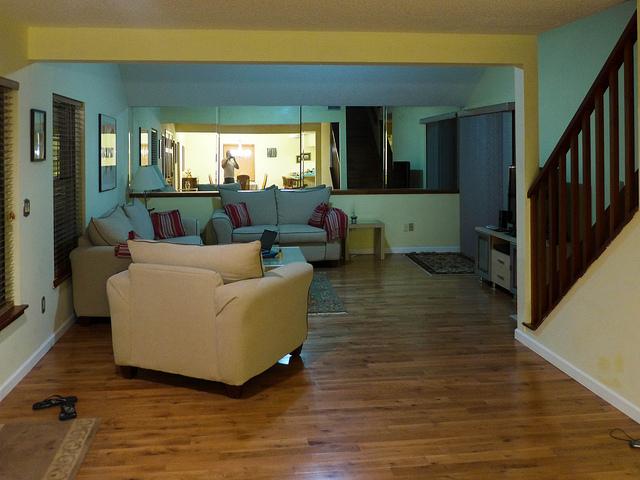Can you spot the guy in the mirror?
Short answer required. Yes. What is the flooring made of?
Concise answer only. Wood. What room is this a picture of?
Write a very short answer. Living room. Is painters tape visible?
Be succinct. No. How many stairs at just the bottom?
Quick response, please. 1. What style footwear is on the floor?
Short answer required. Sandals. What color is the wall?
Short answer required. White. 